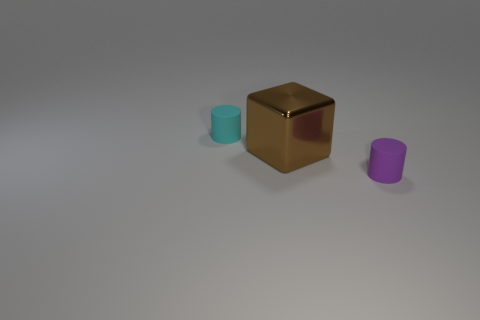How does the lighting affect the appearance of the objects? The lighting in the image is soft and diffused, coming from a direction that casts subtle shadows to the right of the objects. This lighting enhances the reflective properties of the golden cube, gives a sense of depth, and emphasizes the color differences among the objects. It also accentuates the textures, highlighting the cube's sheen contrasted with the cylinders' matte finishes. 